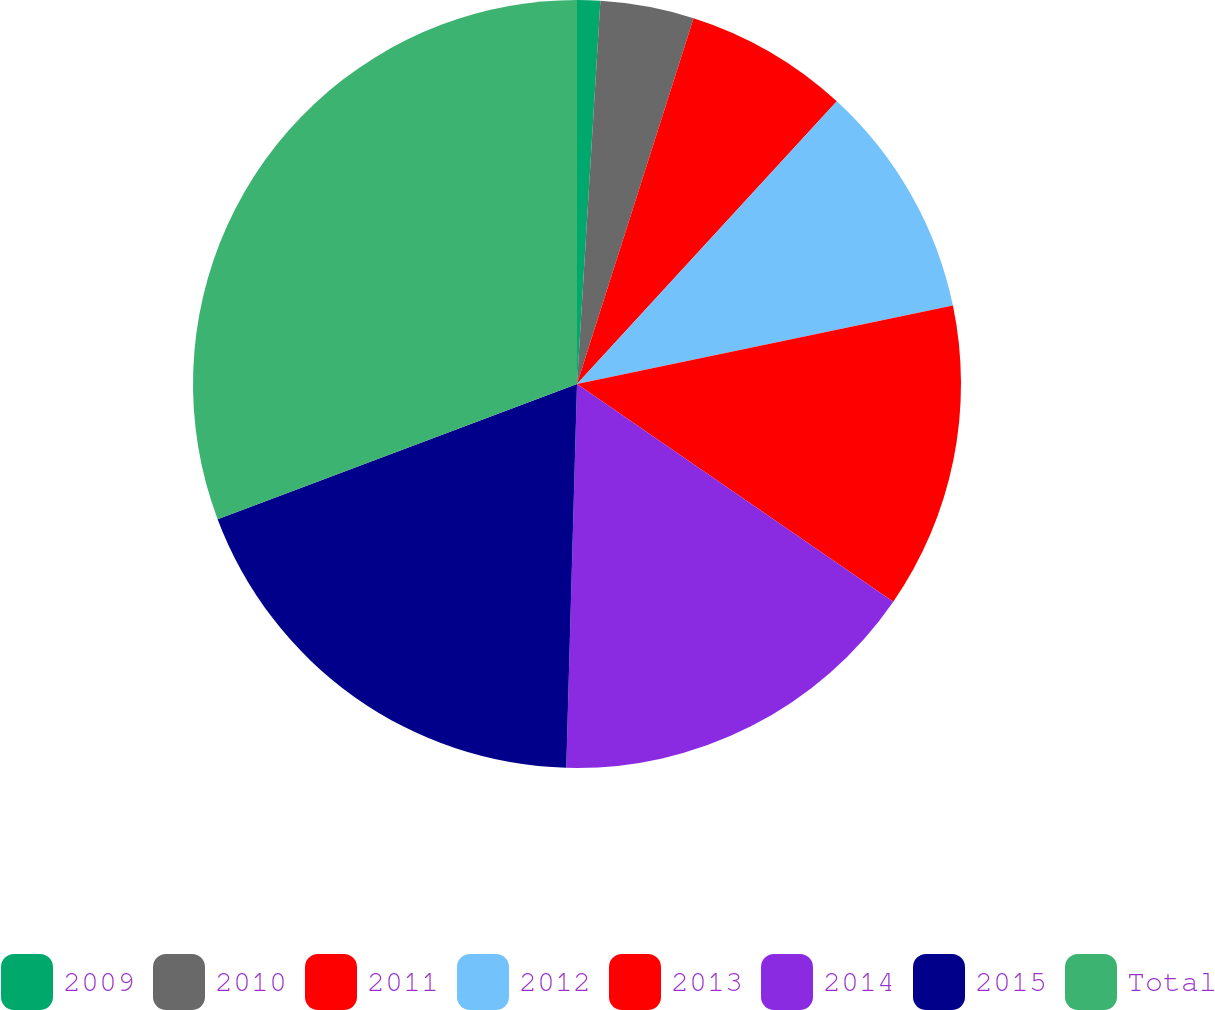<chart> <loc_0><loc_0><loc_500><loc_500><pie_chart><fcel>2009<fcel>2010<fcel>2011<fcel>2012<fcel>2013<fcel>2014<fcel>2015<fcel>Total<nl><fcel>0.97%<fcel>3.94%<fcel>6.92%<fcel>9.9%<fcel>12.87%<fcel>15.85%<fcel>18.83%<fcel>30.73%<nl></chart> 